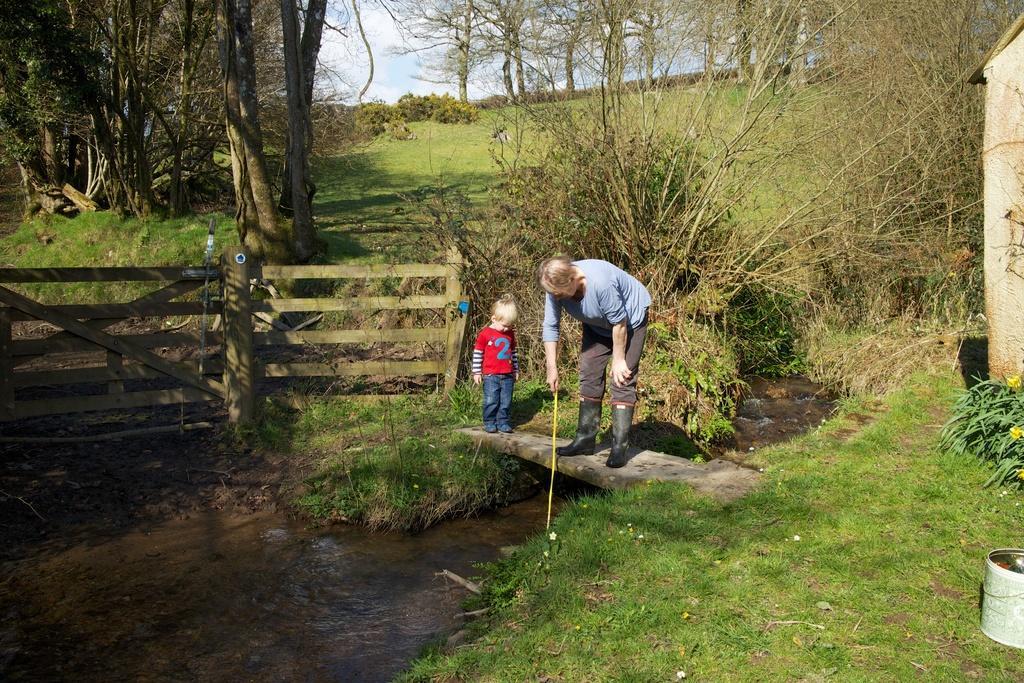Could you give a brief overview of what you see in this image? In this image I can see two persons standing. The person in front wearing blue shirt, brown pant and holding a stick, and the other person is wearing red shirt, blue pant. Background I can see grass and trees in green color, and sky in blue and white color. 